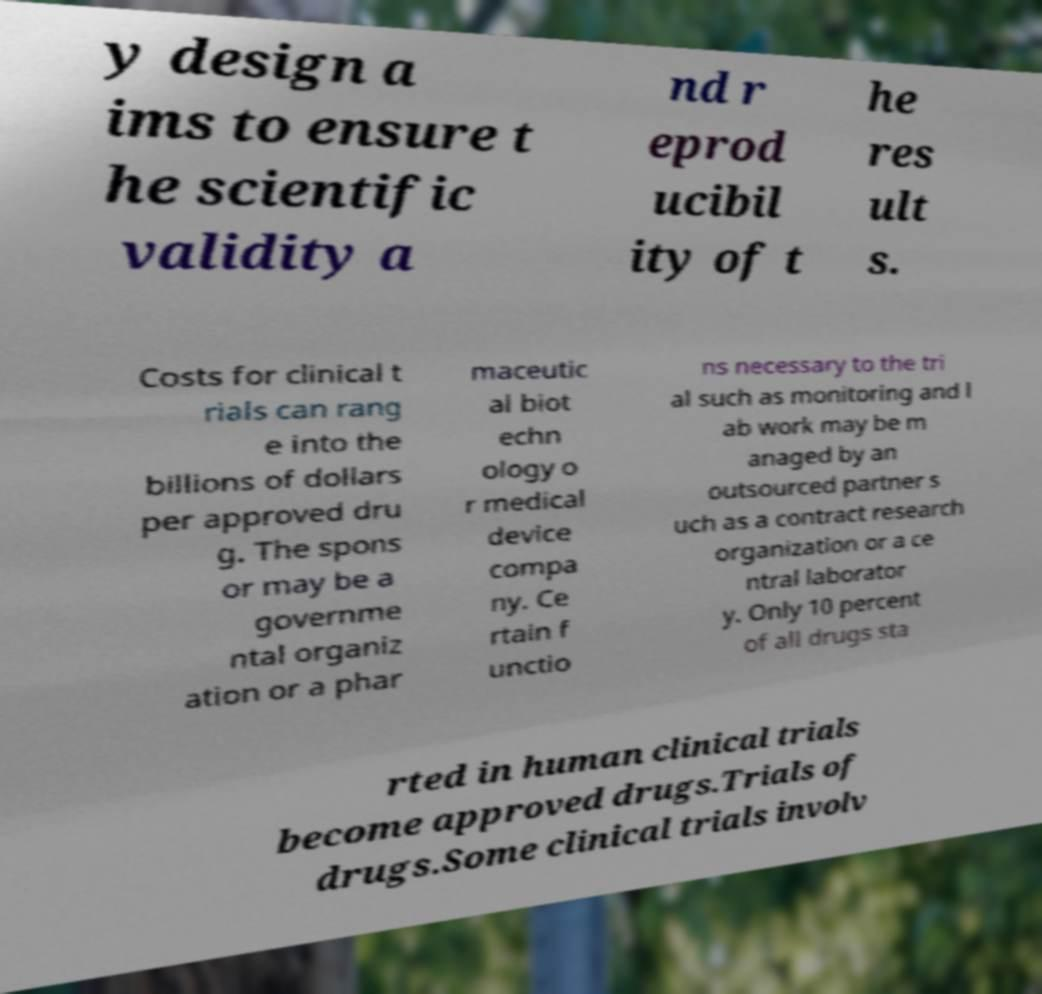Could you assist in decoding the text presented in this image and type it out clearly? y design a ims to ensure t he scientific validity a nd r eprod ucibil ity of t he res ult s. Costs for clinical t rials can rang e into the billions of dollars per approved dru g. The spons or may be a governme ntal organiz ation or a phar maceutic al biot echn ology o r medical device compa ny. Ce rtain f unctio ns necessary to the tri al such as monitoring and l ab work may be m anaged by an outsourced partner s uch as a contract research organization or a ce ntral laborator y. Only 10 percent of all drugs sta rted in human clinical trials become approved drugs.Trials of drugs.Some clinical trials involv 